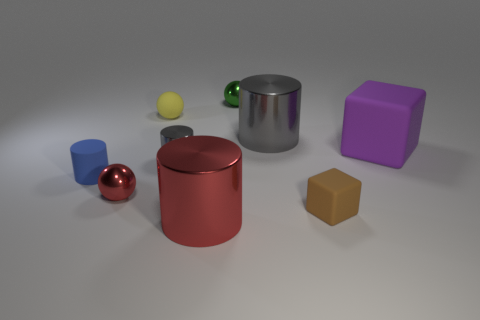Subtract all cyan blocks. Subtract all cyan cylinders. How many blocks are left? 2 Subtract all gray spheres. How many gray cubes are left? 0 Add 4 big purples. How many small greens exist? 0 Subtract all blue rubber objects. Subtract all green rubber blocks. How many objects are left? 8 Add 2 tiny red metallic balls. How many tiny red metallic balls are left? 3 Add 9 large blue matte spheres. How many large blue matte spheres exist? 9 Add 1 yellow metal blocks. How many objects exist? 10 Subtract all purple cubes. How many cubes are left? 1 Subtract all tiny metallic cylinders. How many cylinders are left? 3 Subtract 1 green spheres. How many objects are left? 8 